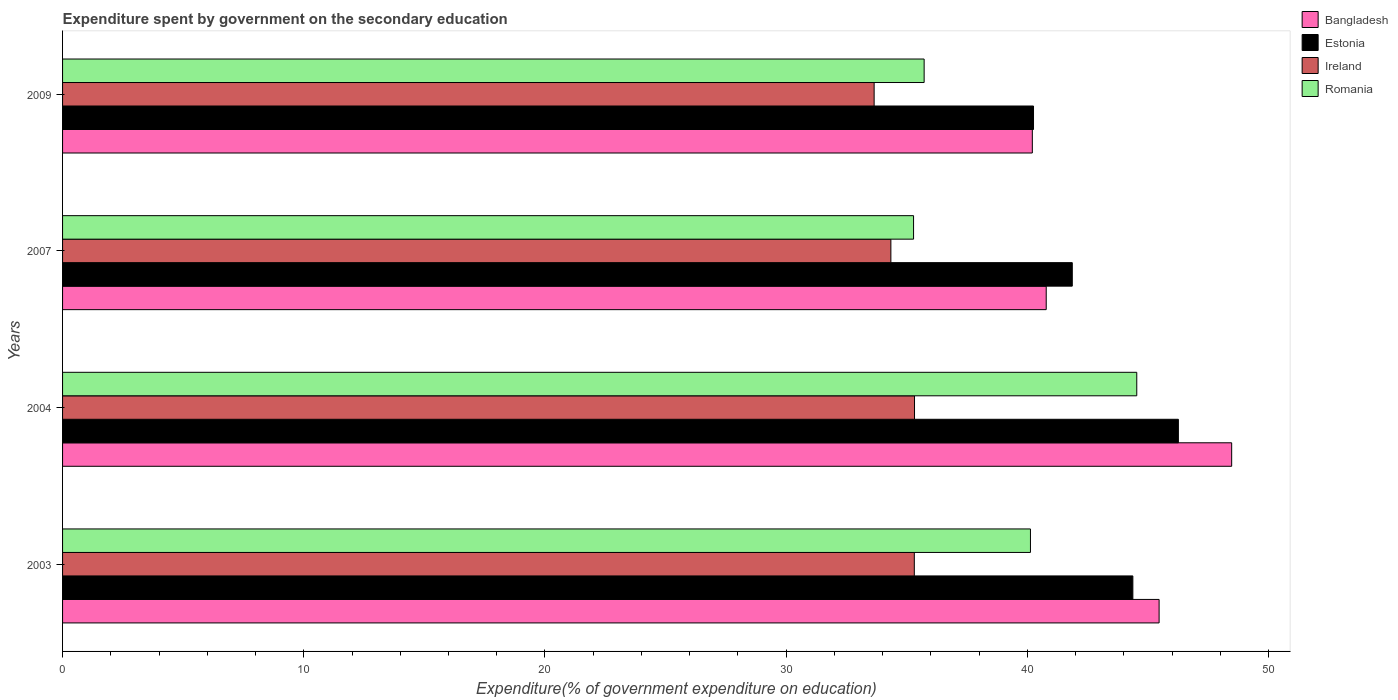Are the number of bars per tick equal to the number of legend labels?
Ensure brevity in your answer.  Yes. Are the number of bars on each tick of the Y-axis equal?
Offer a terse response. Yes. In how many cases, is the number of bars for a given year not equal to the number of legend labels?
Your response must be concise. 0. What is the expenditure spent by government on the secondary education in Ireland in 2004?
Give a very brief answer. 35.32. Across all years, what is the maximum expenditure spent by government on the secondary education in Estonia?
Keep it short and to the point. 46.26. Across all years, what is the minimum expenditure spent by government on the secondary education in Romania?
Ensure brevity in your answer.  35.28. What is the total expenditure spent by government on the secondary education in Bangladesh in the graph?
Offer a terse response. 174.92. What is the difference between the expenditure spent by government on the secondary education in Bangladesh in 2007 and that in 2009?
Provide a short and direct response. 0.58. What is the difference between the expenditure spent by government on the secondary education in Romania in 2009 and the expenditure spent by government on the secondary education in Bangladesh in 2007?
Keep it short and to the point. -5.06. What is the average expenditure spent by government on the secondary education in Ireland per year?
Make the answer very short. 34.66. In the year 2007, what is the difference between the expenditure spent by government on the secondary education in Ireland and expenditure spent by government on the secondary education in Estonia?
Keep it short and to the point. -7.52. What is the ratio of the expenditure spent by government on the secondary education in Estonia in 2007 to that in 2009?
Offer a terse response. 1.04. Is the expenditure spent by government on the secondary education in Romania in 2007 less than that in 2009?
Make the answer very short. Yes. Is the difference between the expenditure spent by government on the secondary education in Ireland in 2004 and 2007 greater than the difference between the expenditure spent by government on the secondary education in Estonia in 2004 and 2007?
Give a very brief answer. No. What is the difference between the highest and the second highest expenditure spent by government on the secondary education in Romania?
Your answer should be compact. 4.41. What is the difference between the highest and the lowest expenditure spent by government on the secondary education in Estonia?
Keep it short and to the point. 6.01. In how many years, is the expenditure spent by government on the secondary education in Estonia greater than the average expenditure spent by government on the secondary education in Estonia taken over all years?
Provide a succinct answer. 2. Is it the case that in every year, the sum of the expenditure spent by government on the secondary education in Estonia and expenditure spent by government on the secondary education in Romania is greater than the sum of expenditure spent by government on the secondary education in Ireland and expenditure spent by government on the secondary education in Bangladesh?
Your response must be concise. No. What does the 4th bar from the top in 2004 represents?
Give a very brief answer. Bangladesh. What does the 2nd bar from the bottom in 2007 represents?
Keep it short and to the point. Estonia. How many bars are there?
Give a very brief answer. 16. Are all the bars in the graph horizontal?
Give a very brief answer. Yes. How many legend labels are there?
Provide a succinct answer. 4. What is the title of the graph?
Your answer should be compact. Expenditure spent by government on the secondary education. Does "Bermuda" appear as one of the legend labels in the graph?
Your answer should be very brief. No. What is the label or title of the X-axis?
Provide a short and direct response. Expenditure(% of government expenditure on education). What is the label or title of the Y-axis?
Offer a terse response. Years. What is the Expenditure(% of government expenditure on education) in Bangladesh in 2003?
Offer a terse response. 45.46. What is the Expenditure(% of government expenditure on education) of Estonia in 2003?
Offer a terse response. 44.37. What is the Expenditure(% of government expenditure on education) in Ireland in 2003?
Make the answer very short. 35.31. What is the Expenditure(% of government expenditure on education) in Romania in 2003?
Provide a short and direct response. 40.13. What is the Expenditure(% of government expenditure on education) of Bangladesh in 2004?
Make the answer very short. 48.47. What is the Expenditure(% of government expenditure on education) in Estonia in 2004?
Offer a terse response. 46.26. What is the Expenditure(% of government expenditure on education) of Ireland in 2004?
Make the answer very short. 35.32. What is the Expenditure(% of government expenditure on education) in Romania in 2004?
Provide a succinct answer. 44.54. What is the Expenditure(% of government expenditure on education) in Bangladesh in 2007?
Offer a terse response. 40.78. What is the Expenditure(% of government expenditure on education) of Estonia in 2007?
Give a very brief answer. 41.86. What is the Expenditure(% of government expenditure on education) of Ireland in 2007?
Keep it short and to the point. 34.34. What is the Expenditure(% of government expenditure on education) of Romania in 2007?
Give a very brief answer. 35.28. What is the Expenditure(% of government expenditure on education) of Bangladesh in 2009?
Offer a very short reply. 40.21. What is the Expenditure(% of government expenditure on education) in Estonia in 2009?
Your answer should be compact. 40.25. What is the Expenditure(% of government expenditure on education) of Ireland in 2009?
Make the answer very short. 33.65. What is the Expenditure(% of government expenditure on education) in Romania in 2009?
Offer a terse response. 35.72. Across all years, what is the maximum Expenditure(% of government expenditure on education) of Bangladesh?
Provide a short and direct response. 48.47. Across all years, what is the maximum Expenditure(% of government expenditure on education) in Estonia?
Provide a succinct answer. 46.26. Across all years, what is the maximum Expenditure(% of government expenditure on education) in Ireland?
Your response must be concise. 35.32. Across all years, what is the maximum Expenditure(% of government expenditure on education) in Romania?
Offer a terse response. 44.54. Across all years, what is the minimum Expenditure(% of government expenditure on education) in Bangladesh?
Provide a succinct answer. 40.21. Across all years, what is the minimum Expenditure(% of government expenditure on education) of Estonia?
Give a very brief answer. 40.25. Across all years, what is the minimum Expenditure(% of government expenditure on education) in Ireland?
Keep it short and to the point. 33.65. Across all years, what is the minimum Expenditure(% of government expenditure on education) in Romania?
Provide a succinct answer. 35.28. What is the total Expenditure(% of government expenditure on education) of Bangladesh in the graph?
Give a very brief answer. 174.92. What is the total Expenditure(% of government expenditure on education) of Estonia in the graph?
Your response must be concise. 172.75. What is the total Expenditure(% of government expenditure on education) in Ireland in the graph?
Offer a very short reply. 138.62. What is the total Expenditure(% of government expenditure on education) in Romania in the graph?
Your response must be concise. 155.67. What is the difference between the Expenditure(% of government expenditure on education) of Bangladesh in 2003 and that in 2004?
Your response must be concise. -3.01. What is the difference between the Expenditure(% of government expenditure on education) of Estonia in 2003 and that in 2004?
Offer a terse response. -1.89. What is the difference between the Expenditure(% of government expenditure on education) of Ireland in 2003 and that in 2004?
Offer a terse response. -0.01. What is the difference between the Expenditure(% of government expenditure on education) in Romania in 2003 and that in 2004?
Your answer should be compact. -4.41. What is the difference between the Expenditure(% of government expenditure on education) of Bangladesh in 2003 and that in 2007?
Provide a succinct answer. 4.68. What is the difference between the Expenditure(% of government expenditure on education) in Estonia in 2003 and that in 2007?
Your response must be concise. 2.51. What is the difference between the Expenditure(% of government expenditure on education) of Ireland in 2003 and that in 2007?
Your answer should be compact. 0.97. What is the difference between the Expenditure(% of government expenditure on education) in Romania in 2003 and that in 2007?
Provide a succinct answer. 4.85. What is the difference between the Expenditure(% of government expenditure on education) in Bangladesh in 2003 and that in 2009?
Provide a short and direct response. 5.26. What is the difference between the Expenditure(% of government expenditure on education) of Estonia in 2003 and that in 2009?
Your answer should be compact. 4.12. What is the difference between the Expenditure(% of government expenditure on education) of Ireland in 2003 and that in 2009?
Your answer should be compact. 1.67. What is the difference between the Expenditure(% of government expenditure on education) in Romania in 2003 and that in 2009?
Offer a terse response. 4.41. What is the difference between the Expenditure(% of government expenditure on education) in Bangladesh in 2004 and that in 2007?
Your response must be concise. 7.69. What is the difference between the Expenditure(% of government expenditure on education) in Estonia in 2004 and that in 2007?
Your answer should be very brief. 4.4. What is the difference between the Expenditure(% of government expenditure on education) in Ireland in 2004 and that in 2007?
Keep it short and to the point. 0.98. What is the difference between the Expenditure(% of government expenditure on education) in Romania in 2004 and that in 2007?
Give a very brief answer. 9.25. What is the difference between the Expenditure(% of government expenditure on education) of Bangladesh in 2004 and that in 2009?
Offer a terse response. 8.27. What is the difference between the Expenditure(% of government expenditure on education) in Estonia in 2004 and that in 2009?
Give a very brief answer. 6.01. What is the difference between the Expenditure(% of government expenditure on education) of Ireland in 2004 and that in 2009?
Keep it short and to the point. 1.67. What is the difference between the Expenditure(% of government expenditure on education) in Romania in 2004 and that in 2009?
Keep it short and to the point. 8.82. What is the difference between the Expenditure(% of government expenditure on education) in Bangladesh in 2007 and that in 2009?
Your answer should be compact. 0.58. What is the difference between the Expenditure(% of government expenditure on education) in Estonia in 2007 and that in 2009?
Give a very brief answer. 1.61. What is the difference between the Expenditure(% of government expenditure on education) in Ireland in 2007 and that in 2009?
Your answer should be very brief. 0.69. What is the difference between the Expenditure(% of government expenditure on education) of Romania in 2007 and that in 2009?
Your answer should be very brief. -0.44. What is the difference between the Expenditure(% of government expenditure on education) in Bangladesh in 2003 and the Expenditure(% of government expenditure on education) in Estonia in 2004?
Make the answer very short. -0.8. What is the difference between the Expenditure(% of government expenditure on education) of Bangladesh in 2003 and the Expenditure(% of government expenditure on education) of Ireland in 2004?
Ensure brevity in your answer.  10.14. What is the difference between the Expenditure(% of government expenditure on education) of Bangladesh in 2003 and the Expenditure(% of government expenditure on education) of Romania in 2004?
Offer a very short reply. 0.93. What is the difference between the Expenditure(% of government expenditure on education) of Estonia in 2003 and the Expenditure(% of government expenditure on education) of Ireland in 2004?
Ensure brevity in your answer.  9.05. What is the difference between the Expenditure(% of government expenditure on education) in Estonia in 2003 and the Expenditure(% of government expenditure on education) in Romania in 2004?
Offer a very short reply. -0.16. What is the difference between the Expenditure(% of government expenditure on education) of Ireland in 2003 and the Expenditure(% of government expenditure on education) of Romania in 2004?
Keep it short and to the point. -9.22. What is the difference between the Expenditure(% of government expenditure on education) of Bangladesh in 2003 and the Expenditure(% of government expenditure on education) of Estonia in 2007?
Provide a succinct answer. 3.6. What is the difference between the Expenditure(% of government expenditure on education) of Bangladesh in 2003 and the Expenditure(% of government expenditure on education) of Ireland in 2007?
Offer a very short reply. 11.12. What is the difference between the Expenditure(% of government expenditure on education) of Bangladesh in 2003 and the Expenditure(% of government expenditure on education) of Romania in 2007?
Your response must be concise. 10.18. What is the difference between the Expenditure(% of government expenditure on education) in Estonia in 2003 and the Expenditure(% of government expenditure on education) in Ireland in 2007?
Make the answer very short. 10.03. What is the difference between the Expenditure(% of government expenditure on education) of Estonia in 2003 and the Expenditure(% of government expenditure on education) of Romania in 2007?
Offer a very short reply. 9.09. What is the difference between the Expenditure(% of government expenditure on education) in Ireland in 2003 and the Expenditure(% of government expenditure on education) in Romania in 2007?
Ensure brevity in your answer.  0.03. What is the difference between the Expenditure(% of government expenditure on education) of Bangladesh in 2003 and the Expenditure(% of government expenditure on education) of Estonia in 2009?
Offer a terse response. 5.21. What is the difference between the Expenditure(% of government expenditure on education) of Bangladesh in 2003 and the Expenditure(% of government expenditure on education) of Ireland in 2009?
Keep it short and to the point. 11.81. What is the difference between the Expenditure(% of government expenditure on education) in Bangladesh in 2003 and the Expenditure(% of government expenditure on education) in Romania in 2009?
Offer a terse response. 9.74. What is the difference between the Expenditure(% of government expenditure on education) in Estonia in 2003 and the Expenditure(% of government expenditure on education) in Ireland in 2009?
Keep it short and to the point. 10.73. What is the difference between the Expenditure(% of government expenditure on education) of Estonia in 2003 and the Expenditure(% of government expenditure on education) of Romania in 2009?
Your answer should be compact. 8.65. What is the difference between the Expenditure(% of government expenditure on education) of Ireland in 2003 and the Expenditure(% of government expenditure on education) of Romania in 2009?
Keep it short and to the point. -0.41. What is the difference between the Expenditure(% of government expenditure on education) in Bangladesh in 2004 and the Expenditure(% of government expenditure on education) in Estonia in 2007?
Offer a very short reply. 6.61. What is the difference between the Expenditure(% of government expenditure on education) of Bangladesh in 2004 and the Expenditure(% of government expenditure on education) of Ireland in 2007?
Provide a succinct answer. 14.13. What is the difference between the Expenditure(% of government expenditure on education) in Bangladesh in 2004 and the Expenditure(% of government expenditure on education) in Romania in 2007?
Your answer should be compact. 13.19. What is the difference between the Expenditure(% of government expenditure on education) in Estonia in 2004 and the Expenditure(% of government expenditure on education) in Ireland in 2007?
Keep it short and to the point. 11.92. What is the difference between the Expenditure(% of government expenditure on education) of Estonia in 2004 and the Expenditure(% of government expenditure on education) of Romania in 2007?
Give a very brief answer. 10.98. What is the difference between the Expenditure(% of government expenditure on education) of Ireland in 2004 and the Expenditure(% of government expenditure on education) of Romania in 2007?
Your response must be concise. 0.04. What is the difference between the Expenditure(% of government expenditure on education) of Bangladesh in 2004 and the Expenditure(% of government expenditure on education) of Estonia in 2009?
Make the answer very short. 8.22. What is the difference between the Expenditure(% of government expenditure on education) in Bangladesh in 2004 and the Expenditure(% of government expenditure on education) in Ireland in 2009?
Your response must be concise. 14.82. What is the difference between the Expenditure(% of government expenditure on education) in Bangladesh in 2004 and the Expenditure(% of government expenditure on education) in Romania in 2009?
Give a very brief answer. 12.75. What is the difference between the Expenditure(% of government expenditure on education) of Estonia in 2004 and the Expenditure(% of government expenditure on education) of Ireland in 2009?
Offer a terse response. 12.61. What is the difference between the Expenditure(% of government expenditure on education) in Estonia in 2004 and the Expenditure(% of government expenditure on education) in Romania in 2009?
Ensure brevity in your answer.  10.54. What is the difference between the Expenditure(% of government expenditure on education) in Ireland in 2004 and the Expenditure(% of government expenditure on education) in Romania in 2009?
Offer a very short reply. -0.4. What is the difference between the Expenditure(% of government expenditure on education) of Bangladesh in 2007 and the Expenditure(% of government expenditure on education) of Estonia in 2009?
Your answer should be very brief. 0.53. What is the difference between the Expenditure(% of government expenditure on education) of Bangladesh in 2007 and the Expenditure(% of government expenditure on education) of Ireland in 2009?
Your answer should be compact. 7.13. What is the difference between the Expenditure(% of government expenditure on education) of Bangladesh in 2007 and the Expenditure(% of government expenditure on education) of Romania in 2009?
Ensure brevity in your answer.  5.06. What is the difference between the Expenditure(% of government expenditure on education) in Estonia in 2007 and the Expenditure(% of government expenditure on education) in Ireland in 2009?
Provide a short and direct response. 8.21. What is the difference between the Expenditure(% of government expenditure on education) of Estonia in 2007 and the Expenditure(% of government expenditure on education) of Romania in 2009?
Ensure brevity in your answer.  6.14. What is the difference between the Expenditure(% of government expenditure on education) of Ireland in 2007 and the Expenditure(% of government expenditure on education) of Romania in 2009?
Keep it short and to the point. -1.38. What is the average Expenditure(% of government expenditure on education) in Bangladesh per year?
Make the answer very short. 43.73. What is the average Expenditure(% of government expenditure on education) in Estonia per year?
Your answer should be very brief. 43.19. What is the average Expenditure(% of government expenditure on education) of Ireland per year?
Ensure brevity in your answer.  34.66. What is the average Expenditure(% of government expenditure on education) in Romania per year?
Give a very brief answer. 38.92. In the year 2003, what is the difference between the Expenditure(% of government expenditure on education) in Bangladesh and Expenditure(% of government expenditure on education) in Estonia?
Your answer should be very brief. 1.09. In the year 2003, what is the difference between the Expenditure(% of government expenditure on education) of Bangladesh and Expenditure(% of government expenditure on education) of Ireland?
Provide a short and direct response. 10.15. In the year 2003, what is the difference between the Expenditure(% of government expenditure on education) in Bangladesh and Expenditure(% of government expenditure on education) in Romania?
Offer a very short reply. 5.33. In the year 2003, what is the difference between the Expenditure(% of government expenditure on education) of Estonia and Expenditure(% of government expenditure on education) of Ireland?
Ensure brevity in your answer.  9.06. In the year 2003, what is the difference between the Expenditure(% of government expenditure on education) in Estonia and Expenditure(% of government expenditure on education) in Romania?
Your answer should be very brief. 4.25. In the year 2003, what is the difference between the Expenditure(% of government expenditure on education) in Ireland and Expenditure(% of government expenditure on education) in Romania?
Ensure brevity in your answer.  -4.82. In the year 2004, what is the difference between the Expenditure(% of government expenditure on education) of Bangladesh and Expenditure(% of government expenditure on education) of Estonia?
Provide a short and direct response. 2.21. In the year 2004, what is the difference between the Expenditure(% of government expenditure on education) in Bangladesh and Expenditure(% of government expenditure on education) in Ireland?
Your answer should be compact. 13.15. In the year 2004, what is the difference between the Expenditure(% of government expenditure on education) of Bangladesh and Expenditure(% of government expenditure on education) of Romania?
Your answer should be compact. 3.93. In the year 2004, what is the difference between the Expenditure(% of government expenditure on education) in Estonia and Expenditure(% of government expenditure on education) in Ireland?
Offer a terse response. 10.94. In the year 2004, what is the difference between the Expenditure(% of government expenditure on education) of Estonia and Expenditure(% of government expenditure on education) of Romania?
Provide a succinct answer. 1.73. In the year 2004, what is the difference between the Expenditure(% of government expenditure on education) in Ireland and Expenditure(% of government expenditure on education) in Romania?
Provide a short and direct response. -9.21. In the year 2007, what is the difference between the Expenditure(% of government expenditure on education) in Bangladesh and Expenditure(% of government expenditure on education) in Estonia?
Your answer should be very brief. -1.08. In the year 2007, what is the difference between the Expenditure(% of government expenditure on education) of Bangladesh and Expenditure(% of government expenditure on education) of Ireland?
Give a very brief answer. 6.44. In the year 2007, what is the difference between the Expenditure(% of government expenditure on education) in Bangladesh and Expenditure(% of government expenditure on education) in Romania?
Offer a very short reply. 5.5. In the year 2007, what is the difference between the Expenditure(% of government expenditure on education) in Estonia and Expenditure(% of government expenditure on education) in Ireland?
Give a very brief answer. 7.52. In the year 2007, what is the difference between the Expenditure(% of government expenditure on education) in Estonia and Expenditure(% of government expenditure on education) in Romania?
Offer a very short reply. 6.58. In the year 2007, what is the difference between the Expenditure(% of government expenditure on education) of Ireland and Expenditure(% of government expenditure on education) of Romania?
Make the answer very short. -0.94. In the year 2009, what is the difference between the Expenditure(% of government expenditure on education) in Bangladesh and Expenditure(% of government expenditure on education) in Estonia?
Keep it short and to the point. -0.05. In the year 2009, what is the difference between the Expenditure(% of government expenditure on education) in Bangladesh and Expenditure(% of government expenditure on education) in Ireland?
Your answer should be very brief. 6.56. In the year 2009, what is the difference between the Expenditure(% of government expenditure on education) of Bangladesh and Expenditure(% of government expenditure on education) of Romania?
Ensure brevity in your answer.  4.49. In the year 2009, what is the difference between the Expenditure(% of government expenditure on education) in Estonia and Expenditure(% of government expenditure on education) in Ireland?
Your response must be concise. 6.61. In the year 2009, what is the difference between the Expenditure(% of government expenditure on education) in Estonia and Expenditure(% of government expenditure on education) in Romania?
Provide a short and direct response. 4.53. In the year 2009, what is the difference between the Expenditure(% of government expenditure on education) of Ireland and Expenditure(% of government expenditure on education) of Romania?
Provide a short and direct response. -2.07. What is the ratio of the Expenditure(% of government expenditure on education) of Bangladesh in 2003 to that in 2004?
Keep it short and to the point. 0.94. What is the ratio of the Expenditure(% of government expenditure on education) of Estonia in 2003 to that in 2004?
Your answer should be very brief. 0.96. What is the ratio of the Expenditure(% of government expenditure on education) of Romania in 2003 to that in 2004?
Make the answer very short. 0.9. What is the ratio of the Expenditure(% of government expenditure on education) of Bangladesh in 2003 to that in 2007?
Offer a very short reply. 1.11. What is the ratio of the Expenditure(% of government expenditure on education) of Estonia in 2003 to that in 2007?
Give a very brief answer. 1.06. What is the ratio of the Expenditure(% of government expenditure on education) of Ireland in 2003 to that in 2007?
Your response must be concise. 1.03. What is the ratio of the Expenditure(% of government expenditure on education) of Romania in 2003 to that in 2007?
Provide a short and direct response. 1.14. What is the ratio of the Expenditure(% of government expenditure on education) in Bangladesh in 2003 to that in 2009?
Keep it short and to the point. 1.13. What is the ratio of the Expenditure(% of government expenditure on education) of Estonia in 2003 to that in 2009?
Your answer should be very brief. 1.1. What is the ratio of the Expenditure(% of government expenditure on education) of Ireland in 2003 to that in 2009?
Provide a succinct answer. 1.05. What is the ratio of the Expenditure(% of government expenditure on education) in Romania in 2003 to that in 2009?
Give a very brief answer. 1.12. What is the ratio of the Expenditure(% of government expenditure on education) of Bangladesh in 2004 to that in 2007?
Your response must be concise. 1.19. What is the ratio of the Expenditure(% of government expenditure on education) in Estonia in 2004 to that in 2007?
Provide a succinct answer. 1.11. What is the ratio of the Expenditure(% of government expenditure on education) in Ireland in 2004 to that in 2007?
Offer a terse response. 1.03. What is the ratio of the Expenditure(% of government expenditure on education) in Romania in 2004 to that in 2007?
Your answer should be compact. 1.26. What is the ratio of the Expenditure(% of government expenditure on education) of Bangladesh in 2004 to that in 2009?
Offer a terse response. 1.21. What is the ratio of the Expenditure(% of government expenditure on education) of Estonia in 2004 to that in 2009?
Ensure brevity in your answer.  1.15. What is the ratio of the Expenditure(% of government expenditure on education) in Ireland in 2004 to that in 2009?
Your answer should be very brief. 1.05. What is the ratio of the Expenditure(% of government expenditure on education) in Romania in 2004 to that in 2009?
Offer a terse response. 1.25. What is the ratio of the Expenditure(% of government expenditure on education) of Bangladesh in 2007 to that in 2009?
Provide a succinct answer. 1.01. What is the ratio of the Expenditure(% of government expenditure on education) in Estonia in 2007 to that in 2009?
Provide a succinct answer. 1.04. What is the ratio of the Expenditure(% of government expenditure on education) of Ireland in 2007 to that in 2009?
Your answer should be compact. 1.02. What is the ratio of the Expenditure(% of government expenditure on education) in Romania in 2007 to that in 2009?
Make the answer very short. 0.99. What is the difference between the highest and the second highest Expenditure(% of government expenditure on education) in Bangladesh?
Provide a succinct answer. 3.01. What is the difference between the highest and the second highest Expenditure(% of government expenditure on education) of Estonia?
Offer a terse response. 1.89. What is the difference between the highest and the second highest Expenditure(% of government expenditure on education) of Ireland?
Keep it short and to the point. 0.01. What is the difference between the highest and the second highest Expenditure(% of government expenditure on education) in Romania?
Your answer should be compact. 4.41. What is the difference between the highest and the lowest Expenditure(% of government expenditure on education) of Bangladesh?
Make the answer very short. 8.27. What is the difference between the highest and the lowest Expenditure(% of government expenditure on education) in Estonia?
Keep it short and to the point. 6.01. What is the difference between the highest and the lowest Expenditure(% of government expenditure on education) in Ireland?
Your response must be concise. 1.67. What is the difference between the highest and the lowest Expenditure(% of government expenditure on education) of Romania?
Your response must be concise. 9.25. 